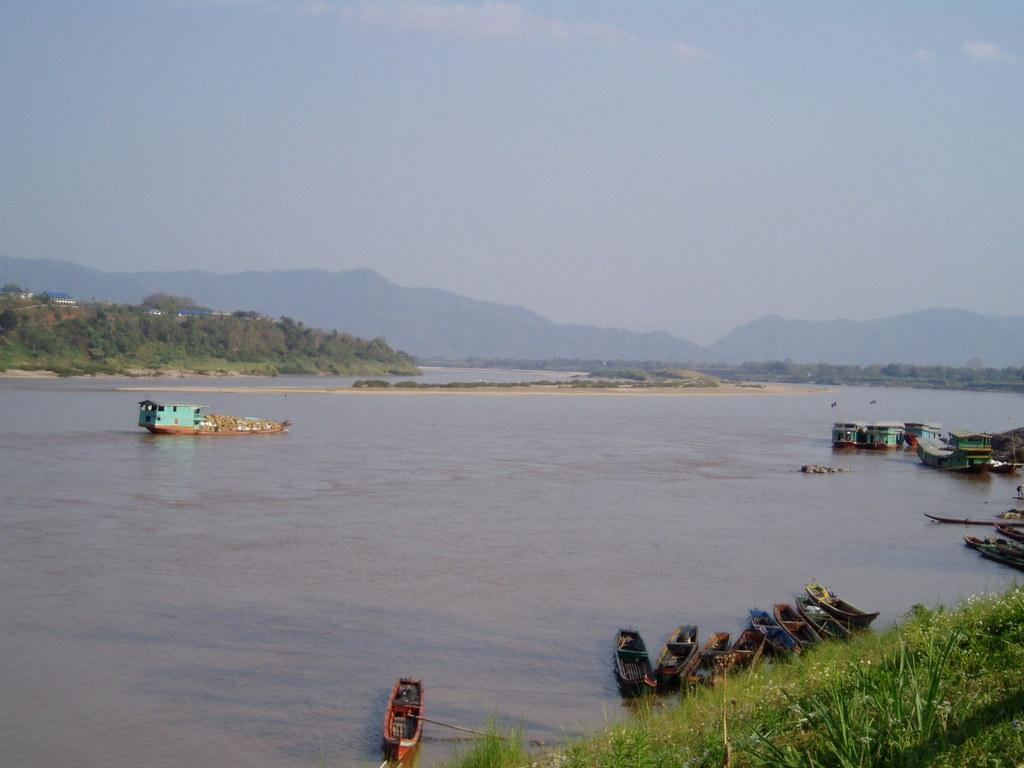What can be seen on the river in the image? There are ships on the river in the image. What type of vegetation is present in the image? There are trees in the image. What type of structures can be seen in the image? There are houses in the image. What type of ground cover is present in the image? There is grass in the image. What type of geographical feature is visible in the image? There are mountains in the image. What part of the natural environment is visible in the image? The sky is visible in the image. What type of debt is being discussed in the image? There is no mention of debt in the image; it features ships on a river, trees, houses, grass, mountains, and the sky. What type of seed is being planted in the image? There is no mention of seeds or planting in the image; it features ships on a river, trees, houses, grass, mountains, and the sky. 